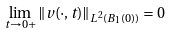Convert formula to latex. <formula><loc_0><loc_0><loc_500><loc_500>\lim _ { t \to 0 + } \| v ( \cdot , t ) \| _ { L ^ { 2 } ( B _ { 1 } ( 0 ) ) } = 0</formula> 